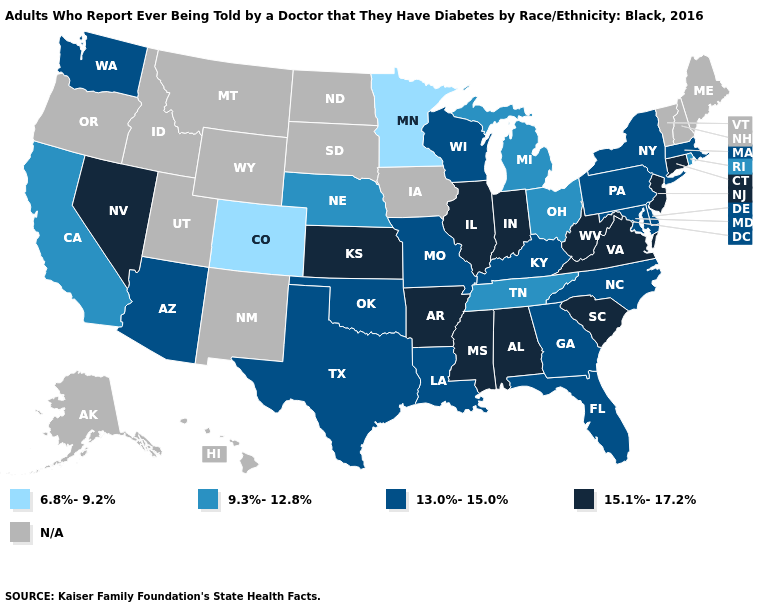Which states have the highest value in the USA?
Short answer required. Alabama, Arkansas, Connecticut, Illinois, Indiana, Kansas, Mississippi, Nevada, New Jersey, South Carolina, Virginia, West Virginia. Does Texas have the lowest value in the USA?
Answer briefly. No. Name the states that have a value in the range 13.0%-15.0%?
Short answer required. Arizona, Delaware, Florida, Georgia, Kentucky, Louisiana, Maryland, Massachusetts, Missouri, New York, North Carolina, Oklahoma, Pennsylvania, Texas, Washington, Wisconsin. What is the lowest value in the MidWest?
Keep it brief. 6.8%-9.2%. How many symbols are there in the legend?
Quick response, please. 5. What is the value of California?
Write a very short answer. 9.3%-12.8%. Which states have the highest value in the USA?
Give a very brief answer. Alabama, Arkansas, Connecticut, Illinois, Indiana, Kansas, Mississippi, Nevada, New Jersey, South Carolina, Virginia, West Virginia. Does Nebraska have the lowest value in the USA?
Concise answer only. No. Name the states that have a value in the range N/A?
Quick response, please. Alaska, Hawaii, Idaho, Iowa, Maine, Montana, New Hampshire, New Mexico, North Dakota, Oregon, South Dakota, Utah, Vermont, Wyoming. Name the states that have a value in the range 15.1%-17.2%?
Write a very short answer. Alabama, Arkansas, Connecticut, Illinois, Indiana, Kansas, Mississippi, Nevada, New Jersey, South Carolina, Virginia, West Virginia. Name the states that have a value in the range N/A?
Keep it brief. Alaska, Hawaii, Idaho, Iowa, Maine, Montana, New Hampshire, New Mexico, North Dakota, Oregon, South Dakota, Utah, Vermont, Wyoming. Which states have the lowest value in the USA?
Concise answer only. Colorado, Minnesota. Among the states that border Missouri , does Kansas have the highest value?
Answer briefly. Yes. What is the highest value in the Northeast ?
Write a very short answer. 15.1%-17.2%. How many symbols are there in the legend?
Keep it brief. 5. 